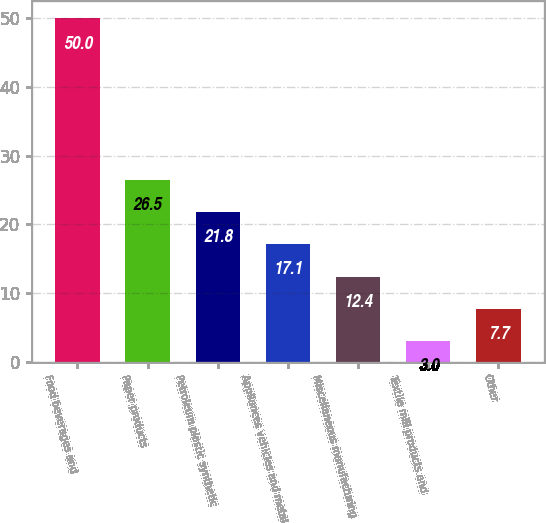Convert chart to OTSL. <chart><loc_0><loc_0><loc_500><loc_500><bar_chart><fcel>Food beverages and<fcel>Paper products<fcel>Petroleum plastic synthetic<fcel>Appliances vehicles and metal<fcel>Miscellaneous manufacturing<fcel>Textile mill products and<fcel>Other<nl><fcel>50<fcel>26.5<fcel>21.8<fcel>17.1<fcel>12.4<fcel>3<fcel>7.7<nl></chart> 